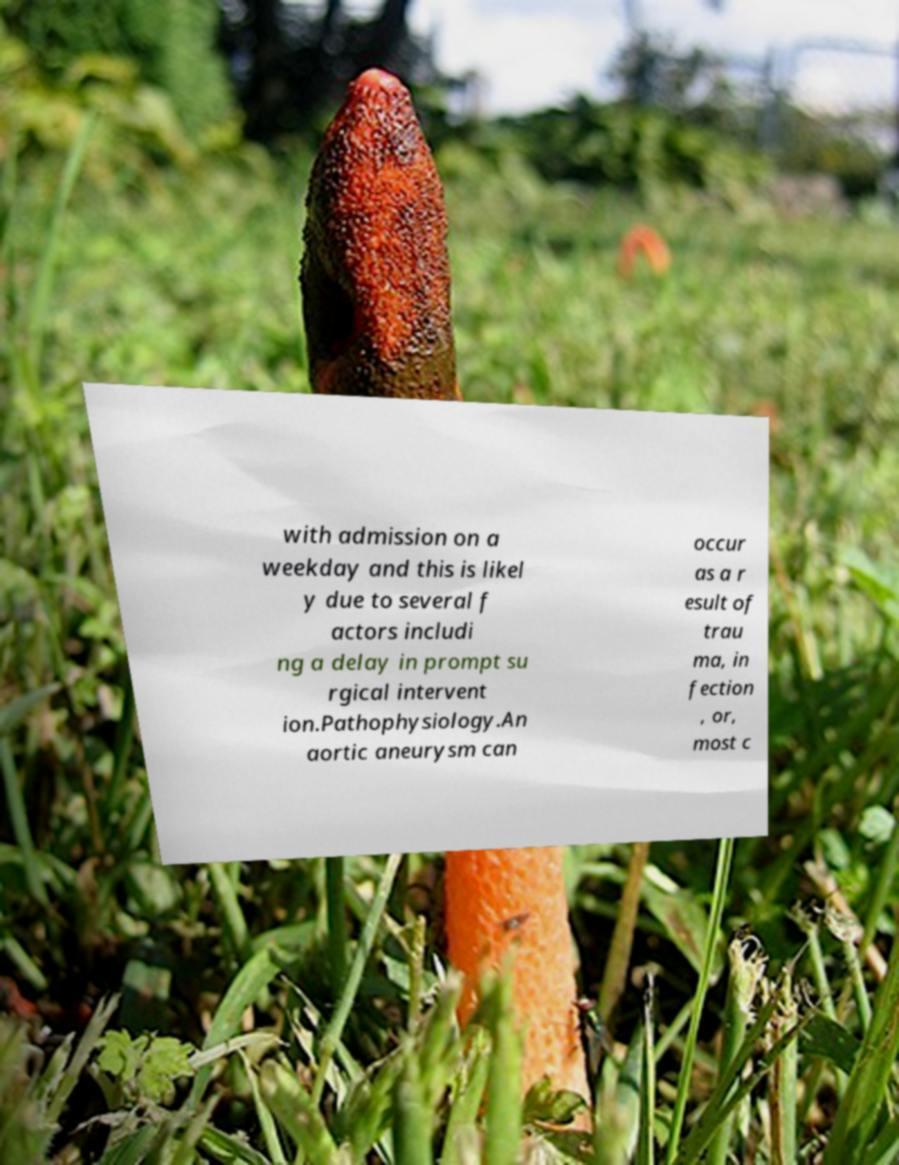I need the written content from this picture converted into text. Can you do that? with admission on a weekday and this is likel y due to several f actors includi ng a delay in prompt su rgical intervent ion.Pathophysiology.An aortic aneurysm can occur as a r esult of trau ma, in fection , or, most c 